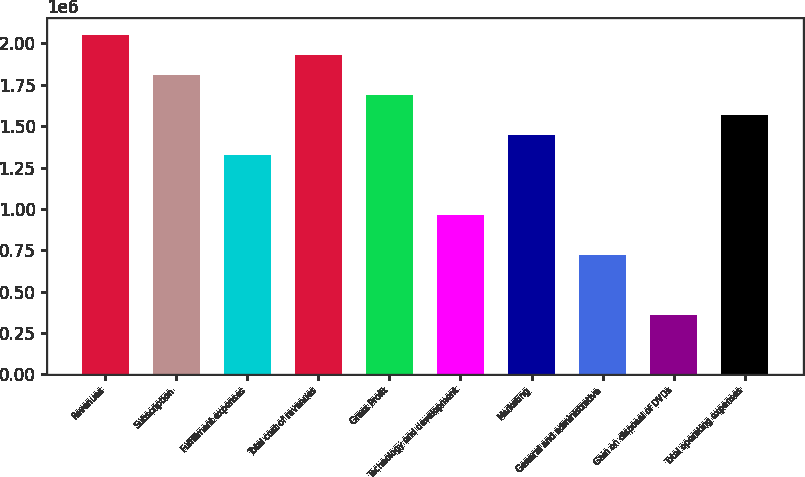Convert chart to OTSL. <chart><loc_0><loc_0><loc_500><loc_500><bar_chart><fcel>Revenues<fcel>Subscription<fcel>Fulfillment expenses<fcel>Total cost of revenues<fcel>Gross Profit<fcel>Technology and development<fcel>Marketing<fcel>General and administrative<fcel>Gain on disposal of DVDs<fcel>Total operating expenses<nl><fcel>2.04908e+06<fcel>1.80801e+06<fcel>1.32587e+06<fcel>1.92854e+06<fcel>1.68748e+06<fcel>964272<fcel>1.44641e+06<fcel>723204<fcel>361603<fcel>1.56694e+06<nl></chart> 